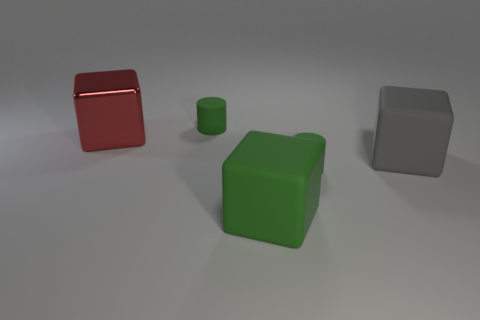Is there any other thing that is made of the same material as the red object?
Make the answer very short. No. How many objects are either matte cylinders behind the red thing or gray metal cylinders?
Ensure brevity in your answer.  1. Is there a gray cube behind the tiny cylinder that is right of the matte cylinder that is behind the red block?
Your answer should be very brief. Yes. What number of large red matte things are there?
Your answer should be very brief. 0. How many objects are either small cylinders that are in front of the red object or objects behind the large green matte block?
Your answer should be very brief. 4. There is a red cube behind the gray object; is its size the same as the large gray rubber block?
Your response must be concise. Yes. What is the material of the green object that is the same size as the gray matte cube?
Your answer should be compact. Rubber. There is a red thing that is the same shape as the gray object; what material is it?
Ensure brevity in your answer.  Metal. What number of other objects are the same size as the metal thing?
Your answer should be compact. 2. What is the shape of the red metallic thing?
Offer a terse response. Cube. 